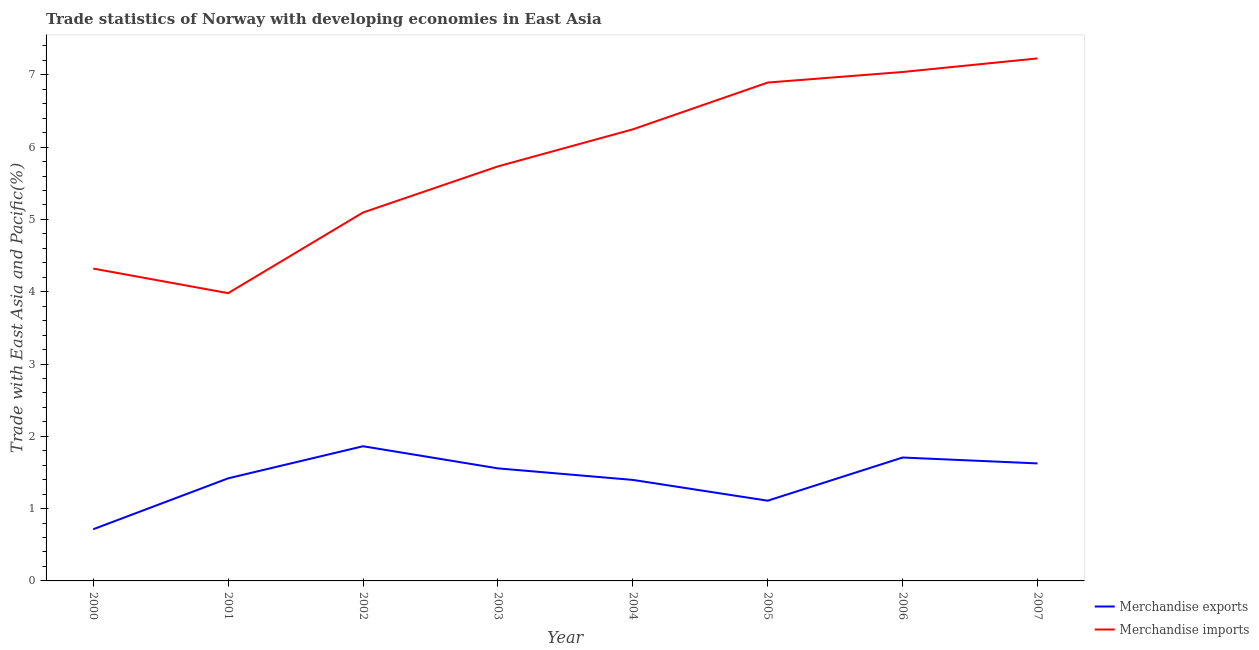Is the number of lines equal to the number of legend labels?
Give a very brief answer. Yes. What is the merchandise exports in 2006?
Provide a succinct answer. 1.71. Across all years, what is the maximum merchandise imports?
Your answer should be compact. 7.23. Across all years, what is the minimum merchandise imports?
Ensure brevity in your answer.  3.98. In which year was the merchandise exports maximum?
Ensure brevity in your answer.  2002. In which year was the merchandise exports minimum?
Ensure brevity in your answer.  2000. What is the total merchandise imports in the graph?
Provide a succinct answer. 46.53. What is the difference between the merchandise imports in 2003 and that in 2005?
Give a very brief answer. -1.16. What is the difference between the merchandise imports in 2004 and the merchandise exports in 2007?
Make the answer very short. 4.62. What is the average merchandise exports per year?
Offer a terse response. 1.42. In the year 2002, what is the difference between the merchandise imports and merchandise exports?
Provide a short and direct response. 3.23. In how many years, is the merchandise exports greater than 3.8 %?
Make the answer very short. 0. What is the ratio of the merchandise imports in 2000 to that in 2002?
Offer a terse response. 0.85. Is the merchandise exports in 2002 less than that in 2003?
Offer a terse response. No. What is the difference between the highest and the second highest merchandise imports?
Offer a very short reply. 0.19. What is the difference between the highest and the lowest merchandise imports?
Provide a short and direct response. 3.25. Is the sum of the merchandise exports in 2003 and 2007 greater than the maximum merchandise imports across all years?
Your response must be concise. No. How many lines are there?
Your response must be concise. 2. How many years are there in the graph?
Offer a terse response. 8. Are the values on the major ticks of Y-axis written in scientific E-notation?
Your response must be concise. No. How are the legend labels stacked?
Keep it short and to the point. Vertical. What is the title of the graph?
Ensure brevity in your answer.  Trade statistics of Norway with developing economies in East Asia. What is the label or title of the X-axis?
Your answer should be compact. Year. What is the label or title of the Y-axis?
Your answer should be compact. Trade with East Asia and Pacific(%). What is the Trade with East Asia and Pacific(%) of Merchandise exports in 2000?
Offer a very short reply. 0.71. What is the Trade with East Asia and Pacific(%) in Merchandise imports in 2000?
Provide a short and direct response. 4.32. What is the Trade with East Asia and Pacific(%) in Merchandise exports in 2001?
Your response must be concise. 1.42. What is the Trade with East Asia and Pacific(%) of Merchandise imports in 2001?
Make the answer very short. 3.98. What is the Trade with East Asia and Pacific(%) in Merchandise exports in 2002?
Your response must be concise. 1.86. What is the Trade with East Asia and Pacific(%) in Merchandise imports in 2002?
Your answer should be very brief. 5.1. What is the Trade with East Asia and Pacific(%) in Merchandise exports in 2003?
Your answer should be compact. 1.56. What is the Trade with East Asia and Pacific(%) in Merchandise imports in 2003?
Your answer should be compact. 5.73. What is the Trade with East Asia and Pacific(%) in Merchandise exports in 2004?
Your answer should be very brief. 1.4. What is the Trade with East Asia and Pacific(%) in Merchandise imports in 2004?
Provide a succinct answer. 6.25. What is the Trade with East Asia and Pacific(%) of Merchandise exports in 2005?
Make the answer very short. 1.11. What is the Trade with East Asia and Pacific(%) in Merchandise imports in 2005?
Provide a succinct answer. 6.89. What is the Trade with East Asia and Pacific(%) of Merchandise exports in 2006?
Your response must be concise. 1.71. What is the Trade with East Asia and Pacific(%) in Merchandise imports in 2006?
Your answer should be compact. 7.04. What is the Trade with East Asia and Pacific(%) in Merchandise exports in 2007?
Give a very brief answer. 1.63. What is the Trade with East Asia and Pacific(%) of Merchandise imports in 2007?
Your answer should be compact. 7.23. Across all years, what is the maximum Trade with East Asia and Pacific(%) in Merchandise exports?
Give a very brief answer. 1.86. Across all years, what is the maximum Trade with East Asia and Pacific(%) in Merchandise imports?
Offer a terse response. 7.23. Across all years, what is the minimum Trade with East Asia and Pacific(%) of Merchandise exports?
Offer a very short reply. 0.71. Across all years, what is the minimum Trade with East Asia and Pacific(%) in Merchandise imports?
Ensure brevity in your answer.  3.98. What is the total Trade with East Asia and Pacific(%) of Merchandise exports in the graph?
Ensure brevity in your answer.  11.39. What is the total Trade with East Asia and Pacific(%) of Merchandise imports in the graph?
Keep it short and to the point. 46.53. What is the difference between the Trade with East Asia and Pacific(%) in Merchandise exports in 2000 and that in 2001?
Ensure brevity in your answer.  -0.7. What is the difference between the Trade with East Asia and Pacific(%) of Merchandise imports in 2000 and that in 2001?
Provide a succinct answer. 0.34. What is the difference between the Trade with East Asia and Pacific(%) of Merchandise exports in 2000 and that in 2002?
Make the answer very short. -1.15. What is the difference between the Trade with East Asia and Pacific(%) of Merchandise imports in 2000 and that in 2002?
Your response must be concise. -0.78. What is the difference between the Trade with East Asia and Pacific(%) in Merchandise exports in 2000 and that in 2003?
Offer a very short reply. -0.84. What is the difference between the Trade with East Asia and Pacific(%) in Merchandise imports in 2000 and that in 2003?
Offer a terse response. -1.41. What is the difference between the Trade with East Asia and Pacific(%) in Merchandise exports in 2000 and that in 2004?
Your answer should be very brief. -0.68. What is the difference between the Trade with East Asia and Pacific(%) in Merchandise imports in 2000 and that in 2004?
Make the answer very short. -1.93. What is the difference between the Trade with East Asia and Pacific(%) of Merchandise exports in 2000 and that in 2005?
Your response must be concise. -0.39. What is the difference between the Trade with East Asia and Pacific(%) in Merchandise imports in 2000 and that in 2005?
Offer a very short reply. -2.57. What is the difference between the Trade with East Asia and Pacific(%) in Merchandise exports in 2000 and that in 2006?
Provide a short and direct response. -0.99. What is the difference between the Trade with East Asia and Pacific(%) in Merchandise imports in 2000 and that in 2006?
Your response must be concise. -2.72. What is the difference between the Trade with East Asia and Pacific(%) in Merchandise exports in 2000 and that in 2007?
Your answer should be compact. -0.91. What is the difference between the Trade with East Asia and Pacific(%) of Merchandise imports in 2000 and that in 2007?
Offer a very short reply. -2.91. What is the difference between the Trade with East Asia and Pacific(%) of Merchandise exports in 2001 and that in 2002?
Offer a very short reply. -0.44. What is the difference between the Trade with East Asia and Pacific(%) of Merchandise imports in 2001 and that in 2002?
Provide a short and direct response. -1.12. What is the difference between the Trade with East Asia and Pacific(%) in Merchandise exports in 2001 and that in 2003?
Keep it short and to the point. -0.14. What is the difference between the Trade with East Asia and Pacific(%) of Merchandise imports in 2001 and that in 2003?
Keep it short and to the point. -1.75. What is the difference between the Trade with East Asia and Pacific(%) in Merchandise exports in 2001 and that in 2004?
Offer a very short reply. 0.02. What is the difference between the Trade with East Asia and Pacific(%) in Merchandise imports in 2001 and that in 2004?
Ensure brevity in your answer.  -2.27. What is the difference between the Trade with East Asia and Pacific(%) of Merchandise exports in 2001 and that in 2005?
Your answer should be very brief. 0.31. What is the difference between the Trade with East Asia and Pacific(%) in Merchandise imports in 2001 and that in 2005?
Your answer should be very brief. -2.91. What is the difference between the Trade with East Asia and Pacific(%) of Merchandise exports in 2001 and that in 2006?
Your answer should be compact. -0.29. What is the difference between the Trade with East Asia and Pacific(%) in Merchandise imports in 2001 and that in 2006?
Your response must be concise. -3.06. What is the difference between the Trade with East Asia and Pacific(%) of Merchandise exports in 2001 and that in 2007?
Provide a succinct answer. -0.21. What is the difference between the Trade with East Asia and Pacific(%) of Merchandise imports in 2001 and that in 2007?
Offer a terse response. -3.25. What is the difference between the Trade with East Asia and Pacific(%) in Merchandise exports in 2002 and that in 2003?
Your answer should be compact. 0.31. What is the difference between the Trade with East Asia and Pacific(%) of Merchandise imports in 2002 and that in 2003?
Give a very brief answer. -0.64. What is the difference between the Trade with East Asia and Pacific(%) of Merchandise exports in 2002 and that in 2004?
Offer a very short reply. 0.47. What is the difference between the Trade with East Asia and Pacific(%) of Merchandise imports in 2002 and that in 2004?
Give a very brief answer. -1.15. What is the difference between the Trade with East Asia and Pacific(%) in Merchandise exports in 2002 and that in 2005?
Offer a very short reply. 0.75. What is the difference between the Trade with East Asia and Pacific(%) in Merchandise imports in 2002 and that in 2005?
Make the answer very short. -1.8. What is the difference between the Trade with East Asia and Pacific(%) in Merchandise exports in 2002 and that in 2006?
Give a very brief answer. 0.16. What is the difference between the Trade with East Asia and Pacific(%) in Merchandise imports in 2002 and that in 2006?
Your answer should be compact. -1.94. What is the difference between the Trade with East Asia and Pacific(%) of Merchandise exports in 2002 and that in 2007?
Offer a very short reply. 0.24. What is the difference between the Trade with East Asia and Pacific(%) of Merchandise imports in 2002 and that in 2007?
Your response must be concise. -2.13. What is the difference between the Trade with East Asia and Pacific(%) in Merchandise exports in 2003 and that in 2004?
Provide a succinct answer. 0.16. What is the difference between the Trade with East Asia and Pacific(%) in Merchandise imports in 2003 and that in 2004?
Offer a terse response. -0.51. What is the difference between the Trade with East Asia and Pacific(%) of Merchandise exports in 2003 and that in 2005?
Give a very brief answer. 0.45. What is the difference between the Trade with East Asia and Pacific(%) in Merchandise imports in 2003 and that in 2005?
Your answer should be compact. -1.16. What is the difference between the Trade with East Asia and Pacific(%) in Merchandise exports in 2003 and that in 2006?
Offer a terse response. -0.15. What is the difference between the Trade with East Asia and Pacific(%) of Merchandise imports in 2003 and that in 2006?
Your answer should be compact. -1.31. What is the difference between the Trade with East Asia and Pacific(%) of Merchandise exports in 2003 and that in 2007?
Ensure brevity in your answer.  -0.07. What is the difference between the Trade with East Asia and Pacific(%) in Merchandise imports in 2003 and that in 2007?
Give a very brief answer. -1.49. What is the difference between the Trade with East Asia and Pacific(%) in Merchandise exports in 2004 and that in 2005?
Your answer should be very brief. 0.29. What is the difference between the Trade with East Asia and Pacific(%) of Merchandise imports in 2004 and that in 2005?
Give a very brief answer. -0.65. What is the difference between the Trade with East Asia and Pacific(%) of Merchandise exports in 2004 and that in 2006?
Your answer should be very brief. -0.31. What is the difference between the Trade with East Asia and Pacific(%) of Merchandise imports in 2004 and that in 2006?
Ensure brevity in your answer.  -0.79. What is the difference between the Trade with East Asia and Pacific(%) of Merchandise exports in 2004 and that in 2007?
Offer a very short reply. -0.23. What is the difference between the Trade with East Asia and Pacific(%) in Merchandise imports in 2004 and that in 2007?
Provide a short and direct response. -0.98. What is the difference between the Trade with East Asia and Pacific(%) of Merchandise exports in 2005 and that in 2006?
Make the answer very short. -0.6. What is the difference between the Trade with East Asia and Pacific(%) in Merchandise imports in 2005 and that in 2006?
Your response must be concise. -0.15. What is the difference between the Trade with East Asia and Pacific(%) of Merchandise exports in 2005 and that in 2007?
Give a very brief answer. -0.52. What is the difference between the Trade with East Asia and Pacific(%) in Merchandise imports in 2005 and that in 2007?
Ensure brevity in your answer.  -0.33. What is the difference between the Trade with East Asia and Pacific(%) of Merchandise exports in 2006 and that in 2007?
Provide a succinct answer. 0.08. What is the difference between the Trade with East Asia and Pacific(%) in Merchandise imports in 2006 and that in 2007?
Provide a succinct answer. -0.19. What is the difference between the Trade with East Asia and Pacific(%) in Merchandise exports in 2000 and the Trade with East Asia and Pacific(%) in Merchandise imports in 2001?
Offer a very short reply. -3.27. What is the difference between the Trade with East Asia and Pacific(%) of Merchandise exports in 2000 and the Trade with East Asia and Pacific(%) of Merchandise imports in 2002?
Provide a short and direct response. -4.38. What is the difference between the Trade with East Asia and Pacific(%) in Merchandise exports in 2000 and the Trade with East Asia and Pacific(%) in Merchandise imports in 2003?
Your answer should be very brief. -5.02. What is the difference between the Trade with East Asia and Pacific(%) in Merchandise exports in 2000 and the Trade with East Asia and Pacific(%) in Merchandise imports in 2004?
Your answer should be very brief. -5.53. What is the difference between the Trade with East Asia and Pacific(%) in Merchandise exports in 2000 and the Trade with East Asia and Pacific(%) in Merchandise imports in 2005?
Your answer should be very brief. -6.18. What is the difference between the Trade with East Asia and Pacific(%) in Merchandise exports in 2000 and the Trade with East Asia and Pacific(%) in Merchandise imports in 2006?
Provide a succinct answer. -6.32. What is the difference between the Trade with East Asia and Pacific(%) of Merchandise exports in 2000 and the Trade with East Asia and Pacific(%) of Merchandise imports in 2007?
Ensure brevity in your answer.  -6.51. What is the difference between the Trade with East Asia and Pacific(%) of Merchandise exports in 2001 and the Trade with East Asia and Pacific(%) of Merchandise imports in 2002?
Your answer should be very brief. -3.68. What is the difference between the Trade with East Asia and Pacific(%) of Merchandise exports in 2001 and the Trade with East Asia and Pacific(%) of Merchandise imports in 2003?
Ensure brevity in your answer.  -4.31. What is the difference between the Trade with East Asia and Pacific(%) of Merchandise exports in 2001 and the Trade with East Asia and Pacific(%) of Merchandise imports in 2004?
Provide a short and direct response. -4.83. What is the difference between the Trade with East Asia and Pacific(%) in Merchandise exports in 2001 and the Trade with East Asia and Pacific(%) in Merchandise imports in 2005?
Offer a terse response. -5.47. What is the difference between the Trade with East Asia and Pacific(%) of Merchandise exports in 2001 and the Trade with East Asia and Pacific(%) of Merchandise imports in 2006?
Your response must be concise. -5.62. What is the difference between the Trade with East Asia and Pacific(%) in Merchandise exports in 2001 and the Trade with East Asia and Pacific(%) in Merchandise imports in 2007?
Your response must be concise. -5.81. What is the difference between the Trade with East Asia and Pacific(%) of Merchandise exports in 2002 and the Trade with East Asia and Pacific(%) of Merchandise imports in 2003?
Give a very brief answer. -3.87. What is the difference between the Trade with East Asia and Pacific(%) of Merchandise exports in 2002 and the Trade with East Asia and Pacific(%) of Merchandise imports in 2004?
Your response must be concise. -4.38. What is the difference between the Trade with East Asia and Pacific(%) in Merchandise exports in 2002 and the Trade with East Asia and Pacific(%) in Merchandise imports in 2005?
Ensure brevity in your answer.  -5.03. What is the difference between the Trade with East Asia and Pacific(%) of Merchandise exports in 2002 and the Trade with East Asia and Pacific(%) of Merchandise imports in 2006?
Your answer should be very brief. -5.18. What is the difference between the Trade with East Asia and Pacific(%) of Merchandise exports in 2002 and the Trade with East Asia and Pacific(%) of Merchandise imports in 2007?
Provide a short and direct response. -5.36. What is the difference between the Trade with East Asia and Pacific(%) in Merchandise exports in 2003 and the Trade with East Asia and Pacific(%) in Merchandise imports in 2004?
Provide a succinct answer. -4.69. What is the difference between the Trade with East Asia and Pacific(%) of Merchandise exports in 2003 and the Trade with East Asia and Pacific(%) of Merchandise imports in 2005?
Your answer should be very brief. -5.34. What is the difference between the Trade with East Asia and Pacific(%) of Merchandise exports in 2003 and the Trade with East Asia and Pacific(%) of Merchandise imports in 2006?
Offer a terse response. -5.48. What is the difference between the Trade with East Asia and Pacific(%) in Merchandise exports in 2003 and the Trade with East Asia and Pacific(%) in Merchandise imports in 2007?
Keep it short and to the point. -5.67. What is the difference between the Trade with East Asia and Pacific(%) of Merchandise exports in 2004 and the Trade with East Asia and Pacific(%) of Merchandise imports in 2005?
Provide a short and direct response. -5.5. What is the difference between the Trade with East Asia and Pacific(%) in Merchandise exports in 2004 and the Trade with East Asia and Pacific(%) in Merchandise imports in 2006?
Your response must be concise. -5.64. What is the difference between the Trade with East Asia and Pacific(%) of Merchandise exports in 2004 and the Trade with East Asia and Pacific(%) of Merchandise imports in 2007?
Offer a very short reply. -5.83. What is the difference between the Trade with East Asia and Pacific(%) of Merchandise exports in 2005 and the Trade with East Asia and Pacific(%) of Merchandise imports in 2006?
Make the answer very short. -5.93. What is the difference between the Trade with East Asia and Pacific(%) in Merchandise exports in 2005 and the Trade with East Asia and Pacific(%) in Merchandise imports in 2007?
Keep it short and to the point. -6.12. What is the difference between the Trade with East Asia and Pacific(%) of Merchandise exports in 2006 and the Trade with East Asia and Pacific(%) of Merchandise imports in 2007?
Make the answer very short. -5.52. What is the average Trade with East Asia and Pacific(%) of Merchandise exports per year?
Make the answer very short. 1.42. What is the average Trade with East Asia and Pacific(%) in Merchandise imports per year?
Offer a terse response. 5.82. In the year 2000, what is the difference between the Trade with East Asia and Pacific(%) in Merchandise exports and Trade with East Asia and Pacific(%) in Merchandise imports?
Offer a terse response. -3.61. In the year 2001, what is the difference between the Trade with East Asia and Pacific(%) in Merchandise exports and Trade with East Asia and Pacific(%) in Merchandise imports?
Make the answer very short. -2.56. In the year 2002, what is the difference between the Trade with East Asia and Pacific(%) of Merchandise exports and Trade with East Asia and Pacific(%) of Merchandise imports?
Keep it short and to the point. -3.23. In the year 2003, what is the difference between the Trade with East Asia and Pacific(%) of Merchandise exports and Trade with East Asia and Pacific(%) of Merchandise imports?
Your answer should be compact. -4.18. In the year 2004, what is the difference between the Trade with East Asia and Pacific(%) of Merchandise exports and Trade with East Asia and Pacific(%) of Merchandise imports?
Ensure brevity in your answer.  -4.85. In the year 2005, what is the difference between the Trade with East Asia and Pacific(%) of Merchandise exports and Trade with East Asia and Pacific(%) of Merchandise imports?
Offer a very short reply. -5.78. In the year 2006, what is the difference between the Trade with East Asia and Pacific(%) in Merchandise exports and Trade with East Asia and Pacific(%) in Merchandise imports?
Your answer should be very brief. -5.33. In the year 2007, what is the difference between the Trade with East Asia and Pacific(%) in Merchandise exports and Trade with East Asia and Pacific(%) in Merchandise imports?
Your response must be concise. -5.6. What is the ratio of the Trade with East Asia and Pacific(%) in Merchandise exports in 2000 to that in 2001?
Provide a short and direct response. 0.5. What is the ratio of the Trade with East Asia and Pacific(%) in Merchandise imports in 2000 to that in 2001?
Offer a very short reply. 1.09. What is the ratio of the Trade with East Asia and Pacific(%) in Merchandise exports in 2000 to that in 2002?
Provide a short and direct response. 0.38. What is the ratio of the Trade with East Asia and Pacific(%) in Merchandise imports in 2000 to that in 2002?
Offer a very short reply. 0.85. What is the ratio of the Trade with East Asia and Pacific(%) of Merchandise exports in 2000 to that in 2003?
Your answer should be compact. 0.46. What is the ratio of the Trade with East Asia and Pacific(%) of Merchandise imports in 2000 to that in 2003?
Give a very brief answer. 0.75. What is the ratio of the Trade with East Asia and Pacific(%) in Merchandise exports in 2000 to that in 2004?
Provide a succinct answer. 0.51. What is the ratio of the Trade with East Asia and Pacific(%) in Merchandise imports in 2000 to that in 2004?
Ensure brevity in your answer.  0.69. What is the ratio of the Trade with East Asia and Pacific(%) in Merchandise exports in 2000 to that in 2005?
Keep it short and to the point. 0.64. What is the ratio of the Trade with East Asia and Pacific(%) of Merchandise imports in 2000 to that in 2005?
Provide a succinct answer. 0.63. What is the ratio of the Trade with East Asia and Pacific(%) in Merchandise exports in 2000 to that in 2006?
Your answer should be very brief. 0.42. What is the ratio of the Trade with East Asia and Pacific(%) of Merchandise imports in 2000 to that in 2006?
Your response must be concise. 0.61. What is the ratio of the Trade with East Asia and Pacific(%) of Merchandise exports in 2000 to that in 2007?
Offer a very short reply. 0.44. What is the ratio of the Trade with East Asia and Pacific(%) of Merchandise imports in 2000 to that in 2007?
Give a very brief answer. 0.6. What is the ratio of the Trade with East Asia and Pacific(%) of Merchandise exports in 2001 to that in 2002?
Your answer should be very brief. 0.76. What is the ratio of the Trade with East Asia and Pacific(%) of Merchandise imports in 2001 to that in 2002?
Your answer should be very brief. 0.78. What is the ratio of the Trade with East Asia and Pacific(%) in Merchandise exports in 2001 to that in 2003?
Provide a short and direct response. 0.91. What is the ratio of the Trade with East Asia and Pacific(%) in Merchandise imports in 2001 to that in 2003?
Give a very brief answer. 0.69. What is the ratio of the Trade with East Asia and Pacific(%) in Merchandise exports in 2001 to that in 2004?
Keep it short and to the point. 1.02. What is the ratio of the Trade with East Asia and Pacific(%) in Merchandise imports in 2001 to that in 2004?
Provide a succinct answer. 0.64. What is the ratio of the Trade with East Asia and Pacific(%) in Merchandise exports in 2001 to that in 2005?
Provide a succinct answer. 1.28. What is the ratio of the Trade with East Asia and Pacific(%) in Merchandise imports in 2001 to that in 2005?
Keep it short and to the point. 0.58. What is the ratio of the Trade with East Asia and Pacific(%) in Merchandise exports in 2001 to that in 2006?
Ensure brevity in your answer.  0.83. What is the ratio of the Trade with East Asia and Pacific(%) of Merchandise imports in 2001 to that in 2006?
Make the answer very short. 0.57. What is the ratio of the Trade with East Asia and Pacific(%) of Merchandise exports in 2001 to that in 2007?
Provide a succinct answer. 0.87. What is the ratio of the Trade with East Asia and Pacific(%) in Merchandise imports in 2001 to that in 2007?
Give a very brief answer. 0.55. What is the ratio of the Trade with East Asia and Pacific(%) in Merchandise exports in 2002 to that in 2003?
Provide a succinct answer. 1.2. What is the ratio of the Trade with East Asia and Pacific(%) of Merchandise imports in 2002 to that in 2003?
Give a very brief answer. 0.89. What is the ratio of the Trade with East Asia and Pacific(%) in Merchandise exports in 2002 to that in 2004?
Offer a terse response. 1.33. What is the ratio of the Trade with East Asia and Pacific(%) of Merchandise imports in 2002 to that in 2004?
Offer a terse response. 0.82. What is the ratio of the Trade with East Asia and Pacific(%) of Merchandise exports in 2002 to that in 2005?
Make the answer very short. 1.68. What is the ratio of the Trade with East Asia and Pacific(%) of Merchandise imports in 2002 to that in 2005?
Give a very brief answer. 0.74. What is the ratio of the Trade with East Asia and Pacific(%) in Merchandise exports in 2002 to that in 2006?
Give a very brief answer. 1.09. What is the ratio of the Trade with East Asia and Pacific(%) in Merchandise imports in 2002 to that in 2006?
Give a very brief answer. 0.72. What is the ratio of the Trade with East Asia and Pacific(%) in Merchandise exports in 2002 to that in 2007?
Keep it short and to the point. 1.15. What is the ratio of the Trade with East Asia and Pacific(%) in Merchandise imports in 2002 to that in 2007?
Offer a very short reply. 0.71. What is the ratio of the Trade with East Asia and Pacific(%) in Merchandise exports in 2003 to that in 2004?
Provide a short and direct response. 1.11. What is the ratio of the Trade with East Asia and Pacific(%) in Merchandise imports in 2003 to that in 2004?
Offer a terse response. 0.92. What is the ratio of the Trade with East Asia and Pacific(%) of Merchandise exports in 2003 to that in 2005?
Your answer should be very brief. 1.4. What is the ratio of the Trade with East Asia and Pacific(%) of Merchandise imports in 2003 to that in 2005?
Ensure brevity in your answer.  0.83. What is the ratio of the Trade with East Asia and Pacific(%) in Merchandise exports in 2003 to that in 2006?
Your response must be concise. 0.91. What is the ratio of the Trade with East Asia and Pacific(%) in Merchandise imports in 2003 to that in 2006?
Ensure brevity in your answer.  0.81. What is the ratio of the Trade with East Asia and Pacific(%) of Merchandise exports in 2003 to that in 2007?
Make the answer very short. 0.96. What is the ratio of the Trade with East Asia and Pacific(%) in Merchandise imports in 2003 to that in 2007?
Your response must be concise. 0.79. What is the ratio of the Trade with East Asia and Pacific(%) of Merchandise exports in 2004 to that in 2005?
Your answer should be compact. 1.26. What is the ratio of the Trade with East Asia and Pacific(%) of Merchandise imports in 2004 to that in 2005?
Offer a very short reply. 0.91. What is the ratio of the Trade with East Asia and Pacific(%) in Merchandise exports in 2004 to that in 2006?
Offer a very short reply. 0.82. What is the ratio of the Trade with East Asia and Pacific(%) of Merchandise imports in 2004 to that in 2006?
Ensure brevity in your answer.  0.89. What is the ratio of the Trade with East Asia and Pacific(%) of Merchandise exports in 2004 to that in 2007?
Your response must be concise. 0.86. What is the ratio of the Trade with East Asia and Pacific(%) of Merchandise imports in 2004 to that in 2007?
Give a very brief answer. 0.86. What is the ratio of the Trade with East Asia and Pacific(%) of Merchandise exports in 2005 to that in 2006?
Your response must be concise. 0.65. What is the ratio of the Trade with East Asia and Pacific(%) in Merchandise imports in 2005 to that in 2006?
Keep it short and to the point. 0.98. What is the ratio of the Trade with East Asia and Pacific(%) of Merchandise exports in 2005 to that in 2007?
Offer a terse response. 0.68. What is the ratio of the Trade with East Asia and Pacific(%) of Merchandise imports in 2005 to that in 2007?
Keep it short and to the point. 0.95. What is the ratio of the Trade with East Asia and Pacific(%) of Merchandise exports in 2006 to that in 2007?
Offer a very short reply. 1.05. What is the ratio of the Trade with East Asia and Pacific(%) in Merchandise imports in 2006 to that in 2007?
Your answer should be very brief. 0.97. What is the difference between the highest and the second highest Trade with East Asia and Pacific(%) in Merchandise exports?
Make the answer very short. 0.16. What is the difference between the highest and the second highest Trade with East Asia and Pacific(%) of Merchandise imports?
Provide a short and direct response. 0.19. What is the difference between the highest and the lowest Trade with East Asia and Pacific(%) of Merchandise exports?
Provide a short and direct response. 1.15. What is the difference between the highest and the lowest Trade with East Asia and Pacific(%) in Merchandise imports?
Provide a short and direct response. 3.25. 